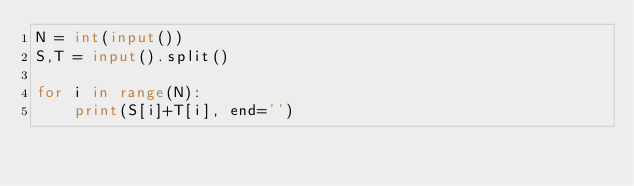<code> <loc_0><loc_0><loc_500><loc_500><_Python_>N = int(input())
S,T = input().split()

for i in range(N):
    print(S[i]+T[i], end='')</code> 